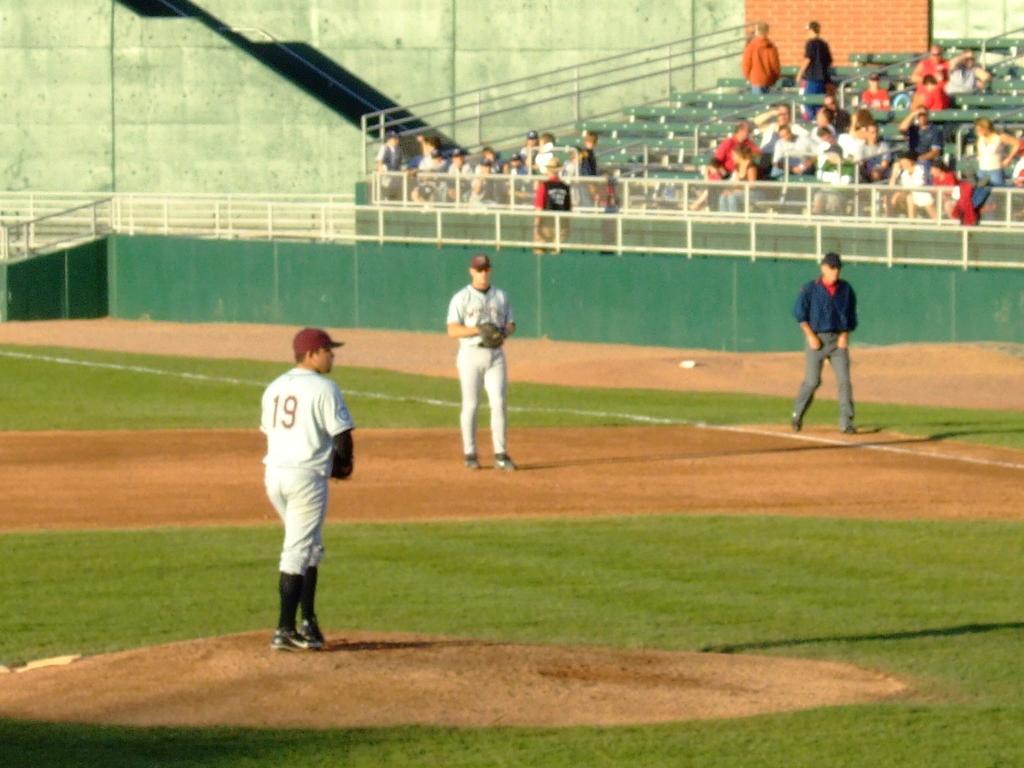Please provide a concise description of this image. In this image we can see the view of a playground, there are two men standing, they are wearing caps, there are men walking, there is a man wearing a cap, there are group of audience, there is a wall towards the top of the image, there is grass towards the bottom of the image. 